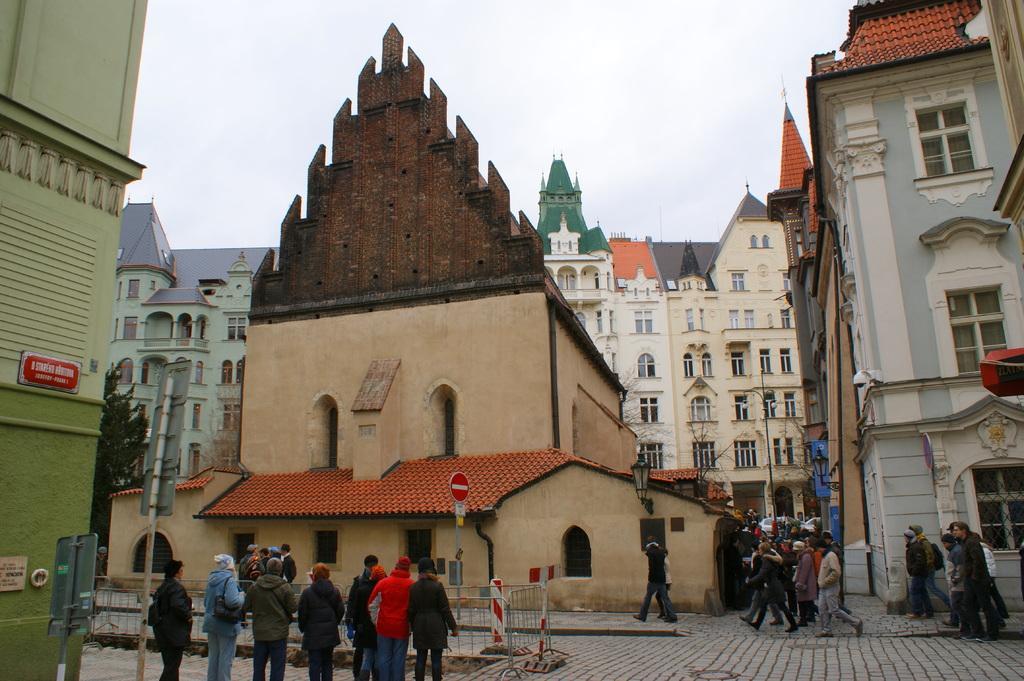In one or two sentences, can you explain what this image depicts? In this image we can see persons, sign board, street lights on the road. In the background we can see buildings, trees and sky. 